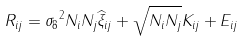<formula> <loc_0><loc_0><loc_500><loc_500>R _ { i j } = { \sigma _ { 8 } } ^ { 2 } N _ { i } N _ { j } \widehat { \xi } _ { i j } + \sqrt { N _ { i } N _ { j } } K _ { i j } + E _ { i j }</formula> 